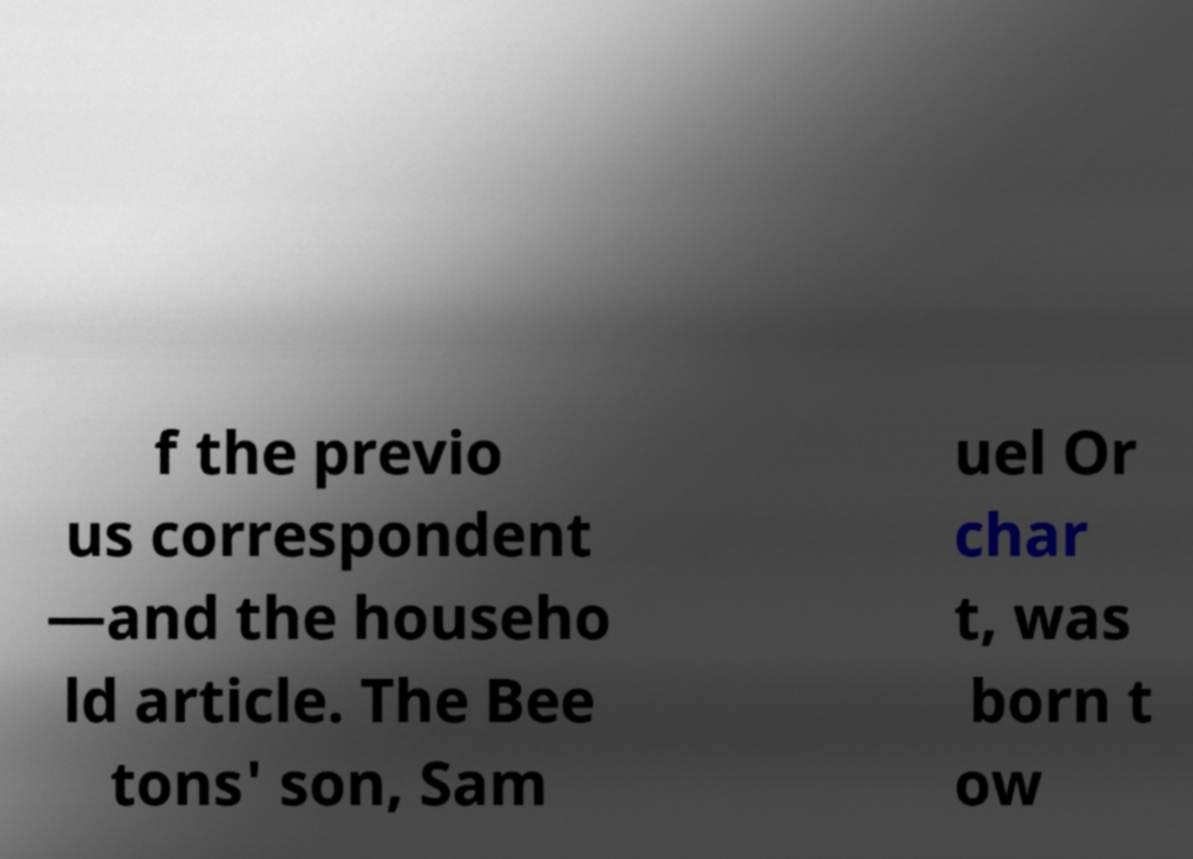Can you accurately transcribe the text from the provided image for me? f the previo us correspondent —and the househo ld article. The Bee tons' son, Sam uel Or char t, was born t ow 